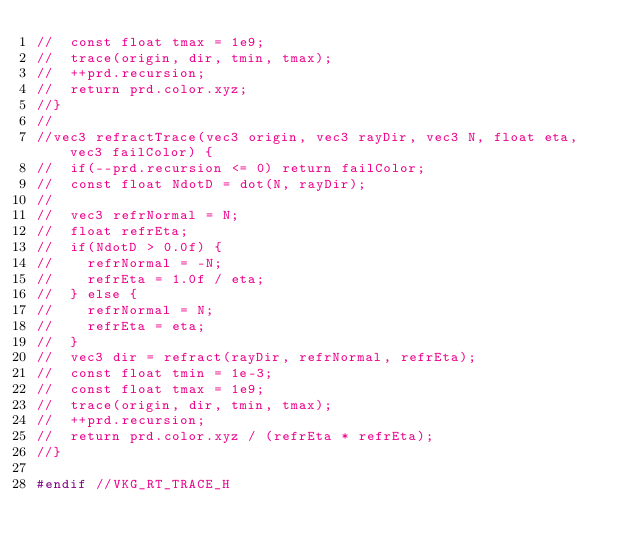<code> <loc_0><loc_0><loc_500><loc_500><_C_>//  const float tmax = 1e9;
//  trace(origin, dir, tmin, tmax);
//  ++prd.recursion;
//  return prd.color.xyz;
//}
//
//vec3 refractTrace(vec3 origin, vec3 rayDir, vec3 N, float eta, vec3 failColor) {
//  if(--prd.recursion <= 0) return failColor;
//  const float NdotD = dot(N, rayDir);
//
//  vec3 refrNormal = N;
//  float refrEta;
//  if(NdotD > 0.0f) {
//    refrNormal = -N;
//    refrEta = 1.0f / eta;
//  } else {
//    refrNormal = N;
//    refrEta = eta;
//  }
//  vec3 dir = refract(rayDir, refrNormal, refrEta);
//  const float tmin = 1e-3;
//  const float tmax = 1e9;
//  trace(origin, dir, tmin, tmax);
//  ++prd.recursion;
//  return prd.color.xyz / (refrEta * refrEta);
//}

#endif //VKG_RT_TRACE_H
</code> 